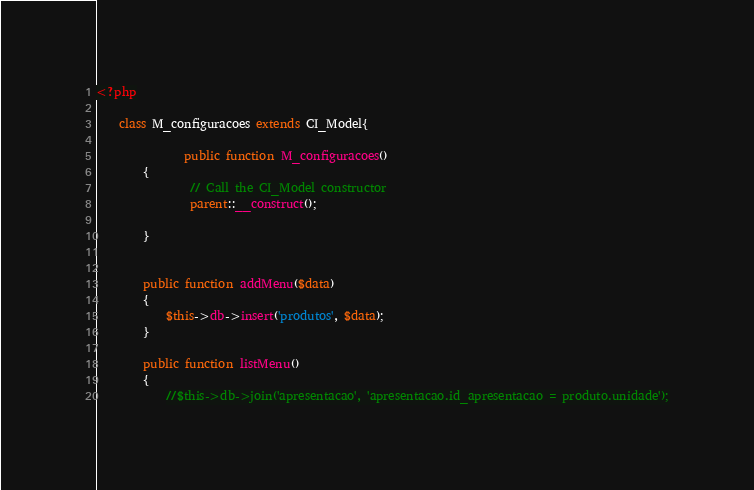<code> <loc_0><loc_0><loc_500><loc_500><_PHP_><?php 

	class M_configuracoes extends CI_Model{
            
               public function M_configuracoes()
        {
                // Call the CI_Model constructor
                parent::__construct();
                
        }
        

		public function addMenu($data)
		{
			$this->db->insert('produtos', $data);
		}

		public function listMenu()
		{
			//$this->db->join('apresentacao', 'apresentacao.id_apresentacao = produto.unidade');</code> 